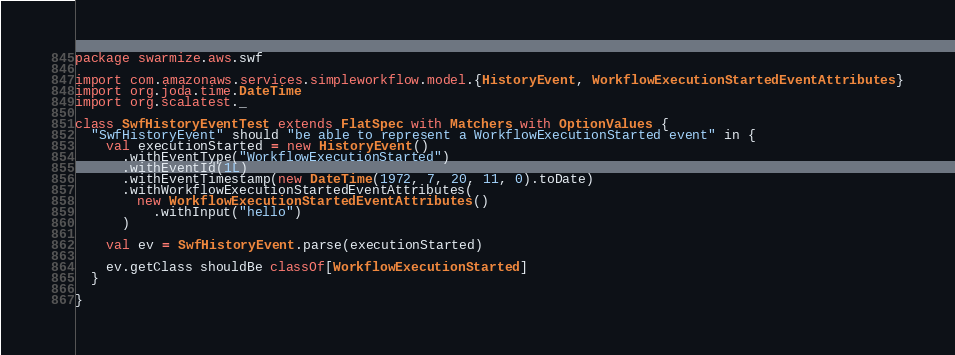<code> <loc_0><loc_0><loc_500><loc_500><_Scala_>package swarmize.aws.swf

import com.amazonaws.services.simpleworkflow.model.{HistoryEvent, WorkflowExecutionStartedEventAttributes}
import org.joda.time.DateTime
import org.scalatest._

class SwfHistoryEventTest extends FlatSpec with Matchers with OptionValues {
  "SwfHistoryEvent" should "be able to represent a WorkflowExecutionStarted event" in {
    val executionStarted = new HistoryEvent()
      .withEventType("WorkflowExecutionStarted")
      .withEventId(1L)
      .withEventTimestamp(new DateTime(1972, 7, 20, 11, 0).toDate)
      .withWorkflowExecutionStartedEventAttributes(
        new WorkflowExecutionStartedEventAttributes()
          .withInput("hello")
      )

    val ev = SwfHistoryEvent.parse(executionStarted)

    ev.getClass shouldBe classOf[WorkflowExecutionStarted]
  }

}
</code> 